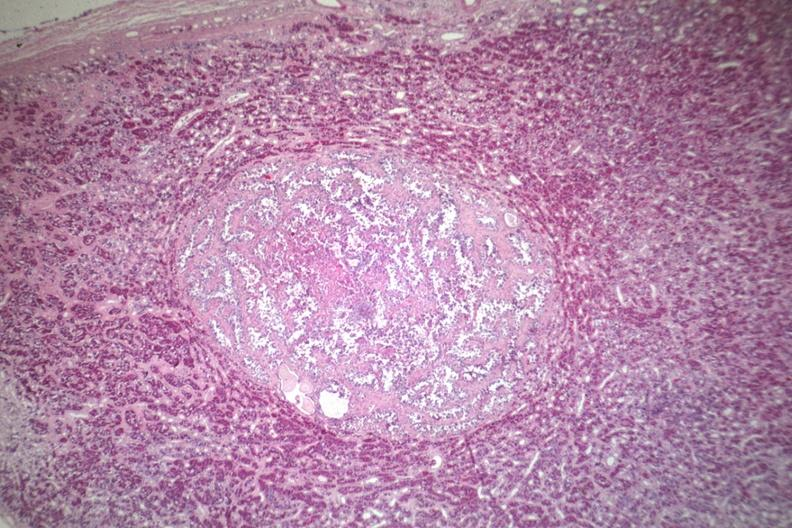where is this part in the figure?
Answer the question using a single word or phrase. Endocrine system 